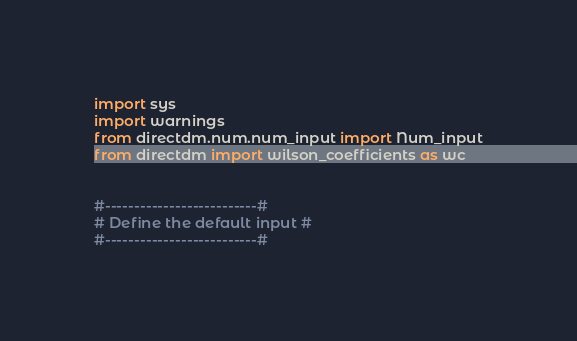Convert code to text. <code><loc_0><loc_0><loc_500><loc_500><_Python_>
import sys
import warnings
from directdm.num.num_input import Num_input
from directdm import wilson_coefficients as wc


#--------------------------#
# Define the default input #
#--------------------------#
</code> 